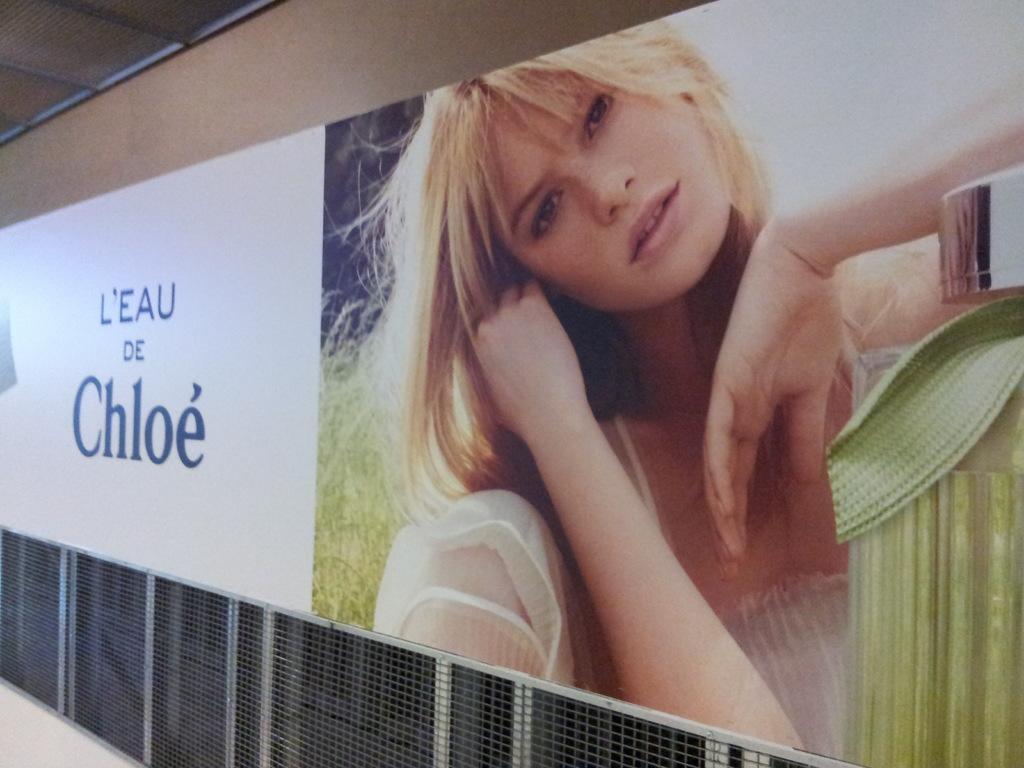Please provide a concise description of this image. In the center of the image we can see a board placed on the wall. At the bottom there is a mesh. 